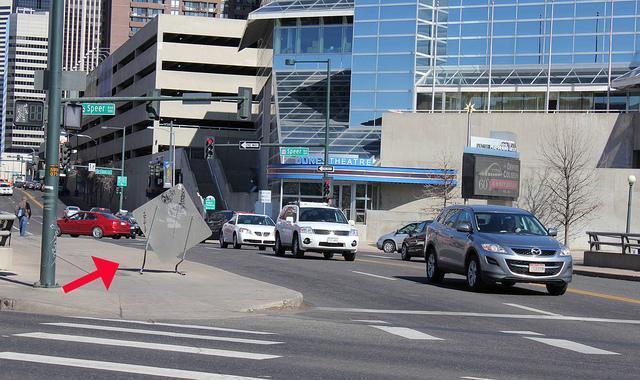How many cars are in the picture?
Give a very brief answer. 2. How many elephants are pictured?
Give a very brief answer. 0. 